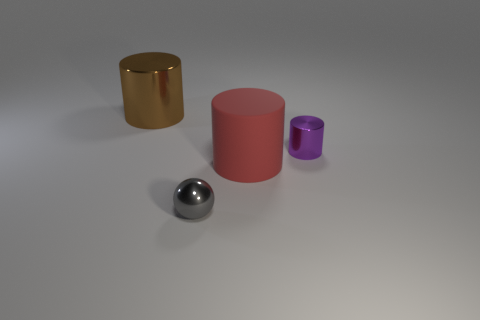Subtract all rubber cylinders. How many cylinders are left? 2 Subtract all brown cylinders. How many cylinders are left? 2 Subtract all cylinders. How many objects are left? 1 Subtract 2 cylinders. How many cylinders are left? 1 Add 3 large green metal cylinders. How many objects exist? 7 Subtract all green cylinders. Subtract all brown blocks. How many cylinders are left? 3 Subtract all yellow cubes. How many yellow spheres are left? 0 Subtract all big red cubes. Subtract all big things. How many objects are left? 2 Add 1 gray metallic spheres. How many gray metallic spheres are left? 2 Add 1 cyan things. How many cyan things exist? 1 